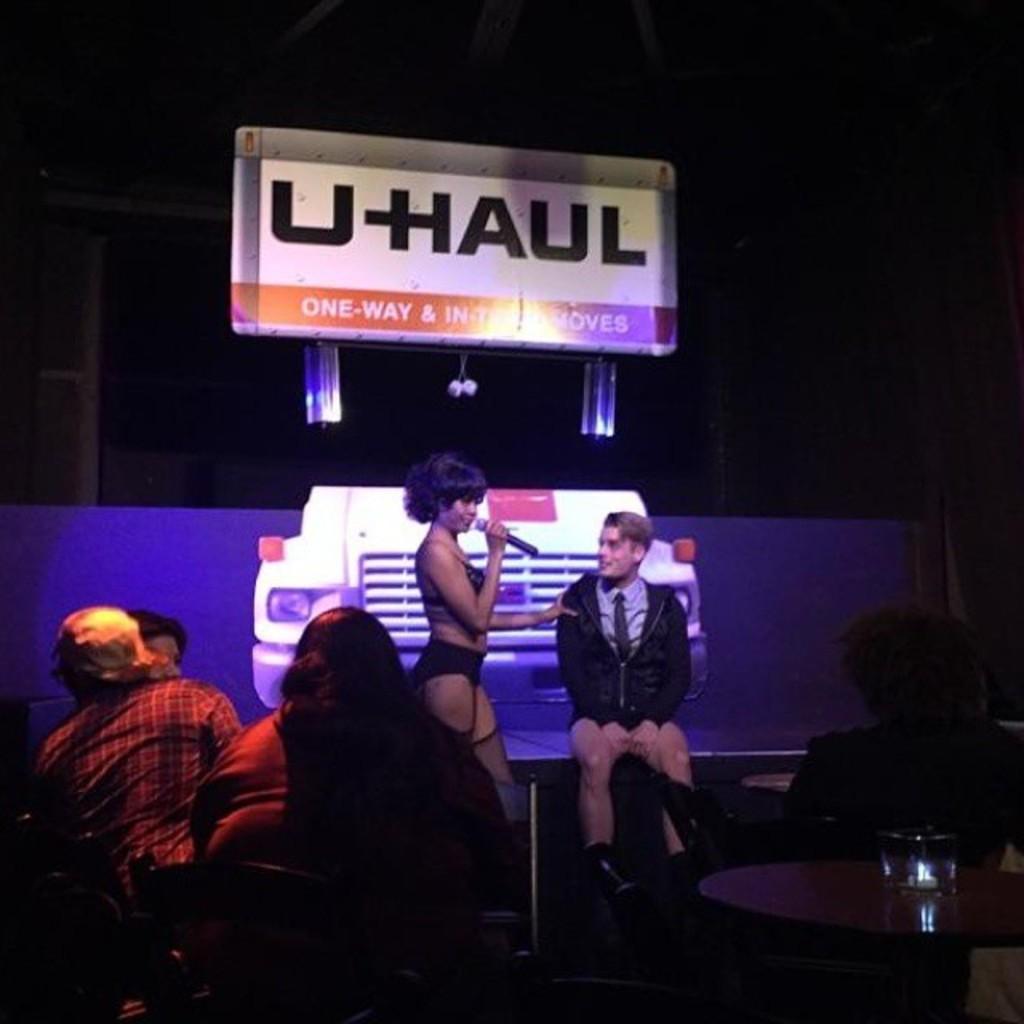Describe this image in one or two sentences. As we can see in the image, there are few people sitting on chairs. In the front there is a table. On table there is a glass and the women who is standing here is holding mic in her hand and there is a banner over here. 